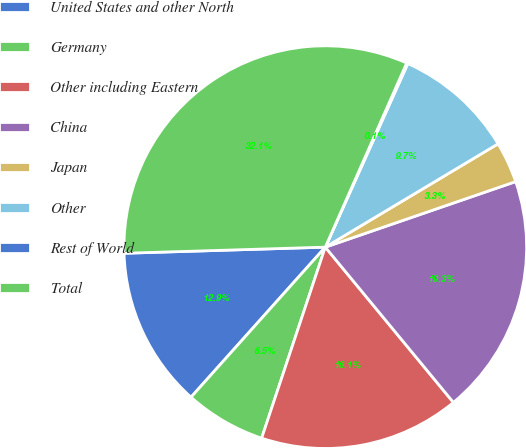Convert chart to OTSL. <chart><loc_0><loc_0><loc_500><loc_500><pie_chart><fcel>United States and other North<fcel>Germany<fcel>Other including Eastern<fcel>China<fcel>Japan<fcel>Other<fcel>Rest of World<fcel>Total<nl><fcel>12.9%<fcel>6.5%<fcel>16.1%<fcel>19.3%<fcel>3.3%<fcel>9.7%<fcel>0.1%<fcel>32.11%<nl></chart> 